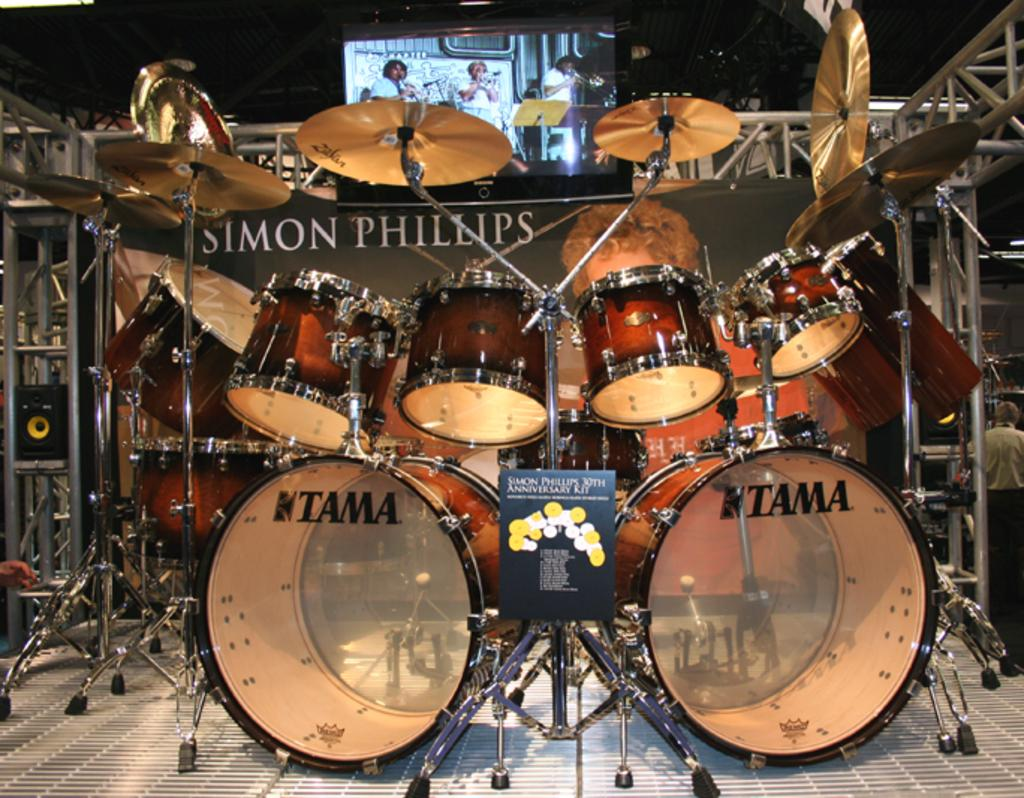What objects are present in the image? There are musical instruments and a screen visible in the image. What can be seen on the screen? Inside the screen, there are three persons sitting. How many ladybugs can be seen on the musical instruments in the image? There are no ladybugs present on the musical instruments in the image. What type of rest is visible in the image? There is no rest visible in the image; it features musical instruments and a screen with three persons sitting inside it. 